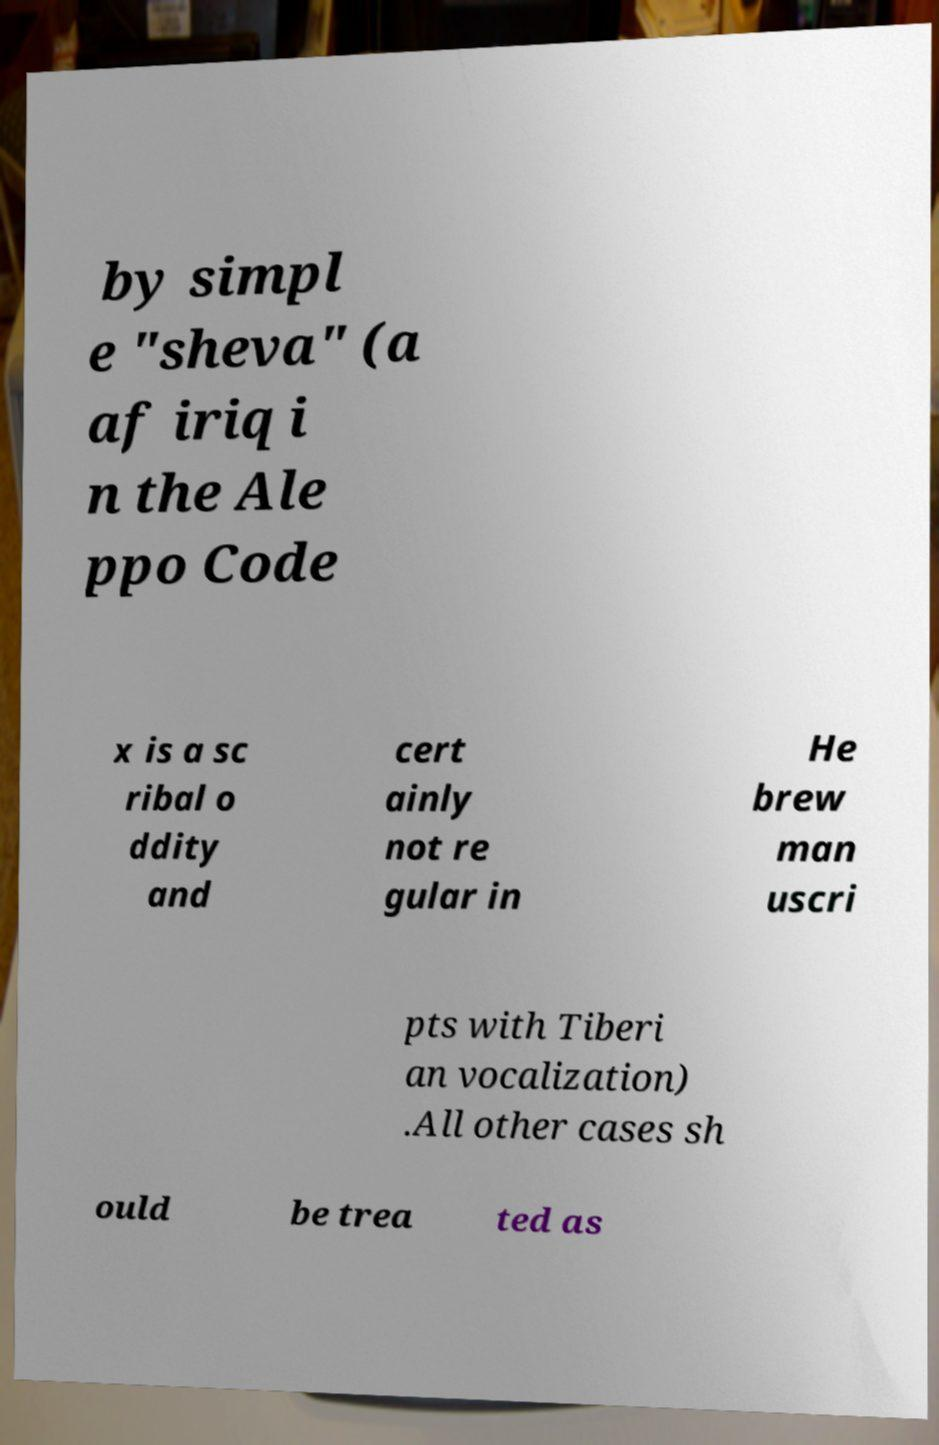Please read and relay the text visible in this image. What does it say? by simpl e "sheva" (a af iriq i n the Ale ppo Code x is a sc ribal o ddity and cert ainly not re gular in He brew man uscri pts with Tiberi an vocalization) .All other cases sh ould be trea ted as 